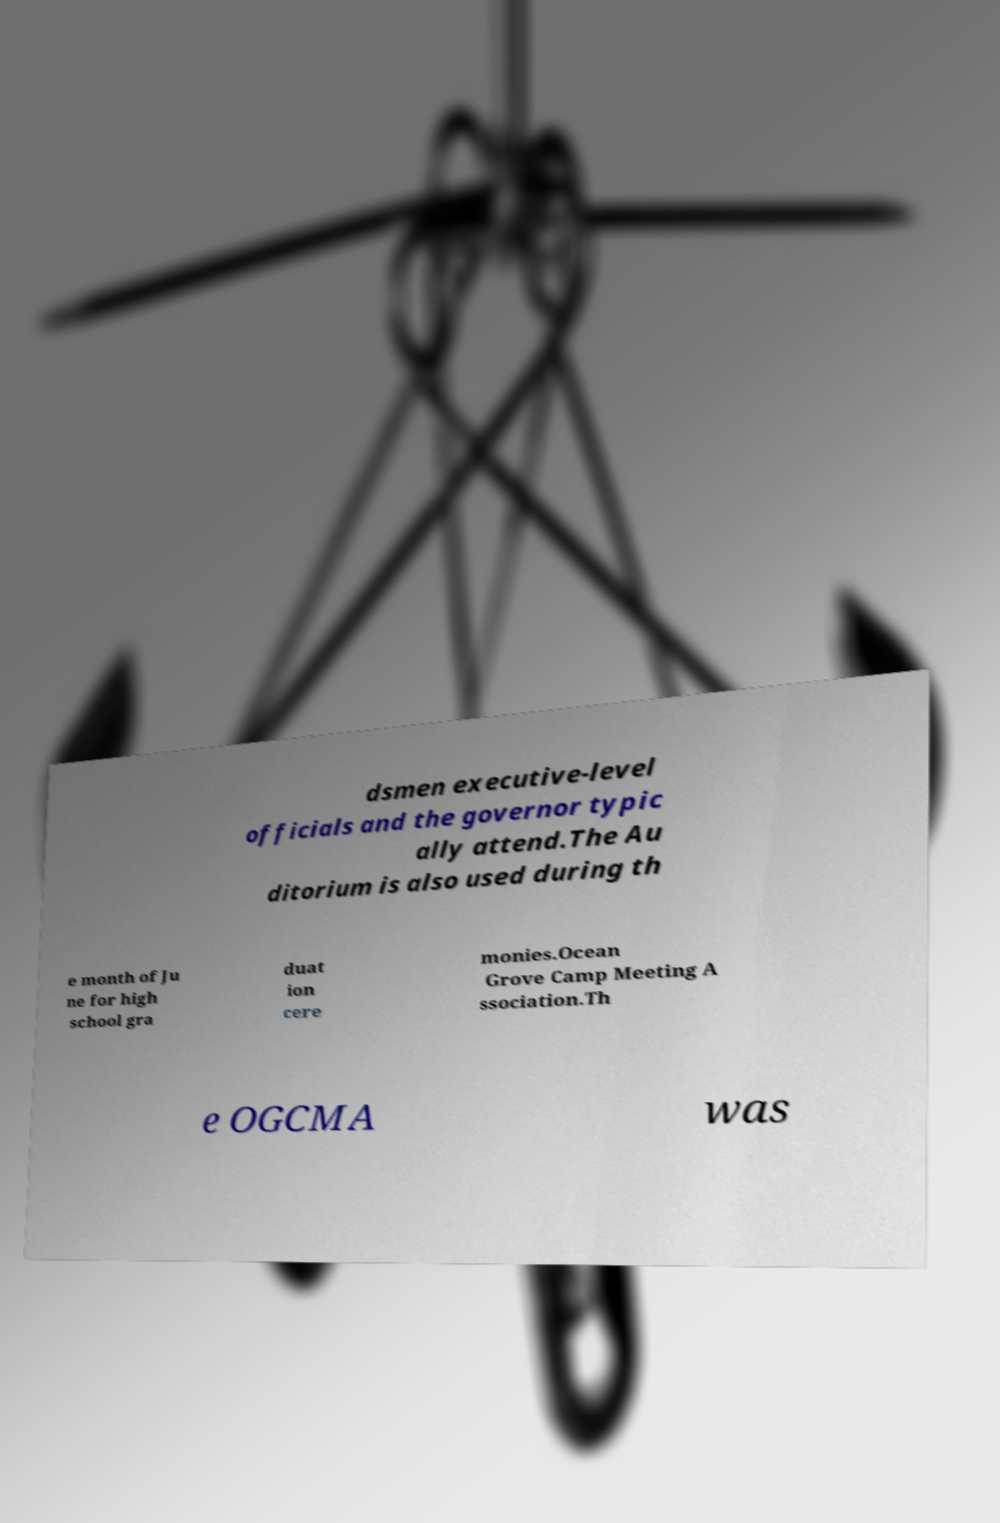Could you extract and type out the text from this image? dsmen executive-level officials and the governor typic ally attend.The Au ditorium is also used during th e month of Ju ne for high school gra duat ion cere monies.Ocean Grove Camp Meeting A ssociation.Th e OGCMA was 